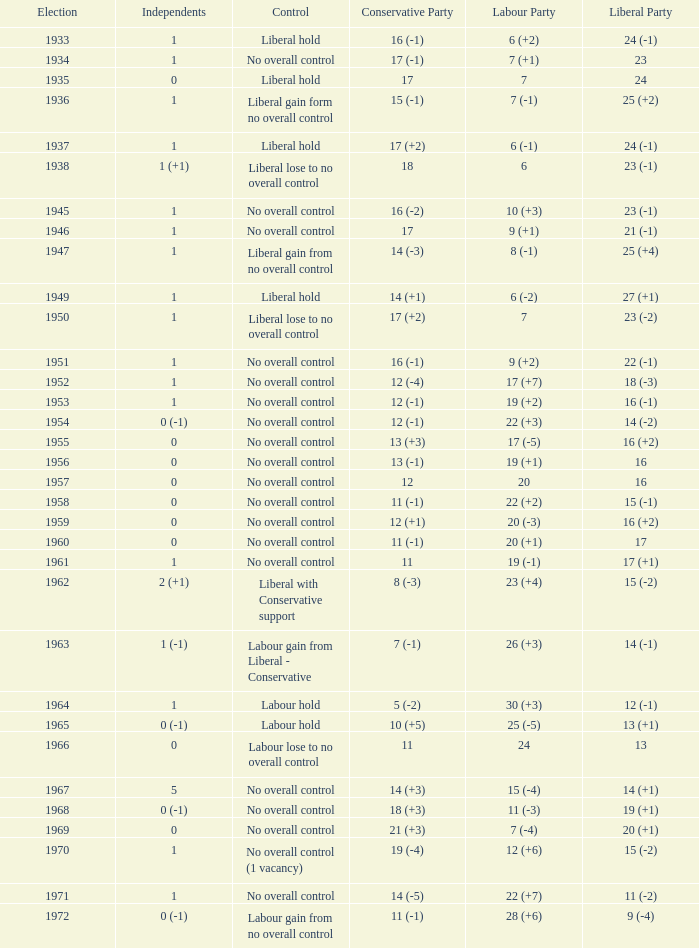What was the control for the year with a Conservative Party result of 10 (+5)? Labour hold. 